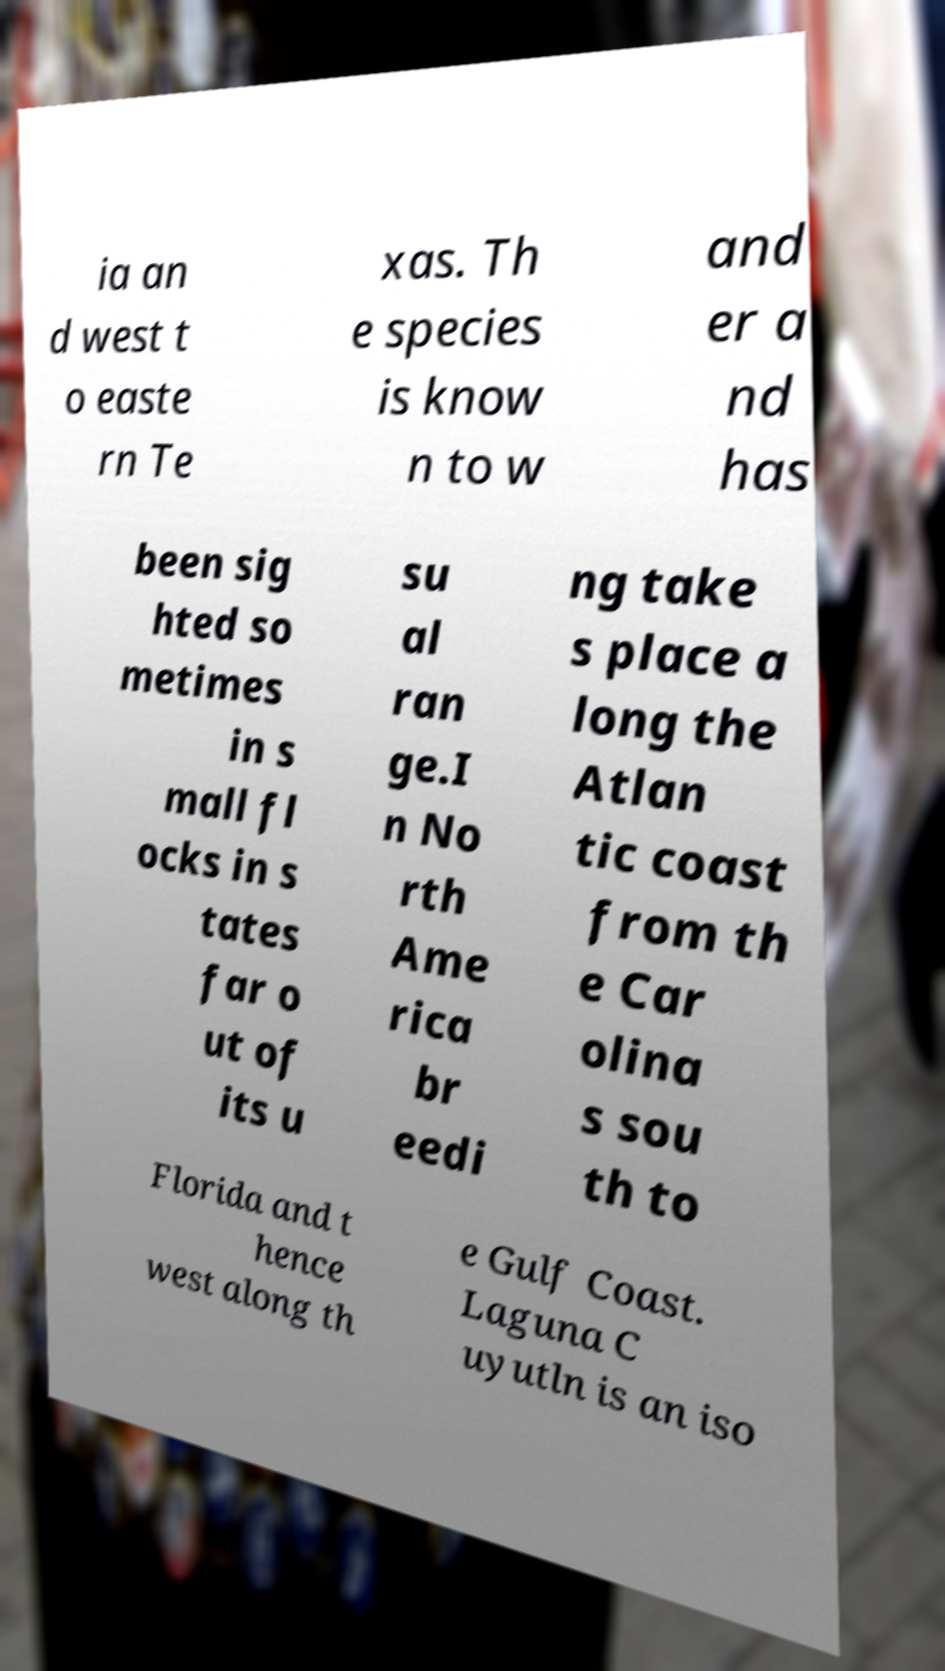Can you accurately transcribe the text from the provided image for me? ia an d west t o easte rn Te xas. Th e species is know n to w and er a nd has been sig hted so metimes in s mall fl ocks in s tates far o ut of its u su al ran ge.I n No rth Ame rica br eedi ng take s place a long the Atlan tic coast from th e Car olina s sou th to Florida and t hence west along th e Gulf Coast. Laguna C uyutln is an iso 